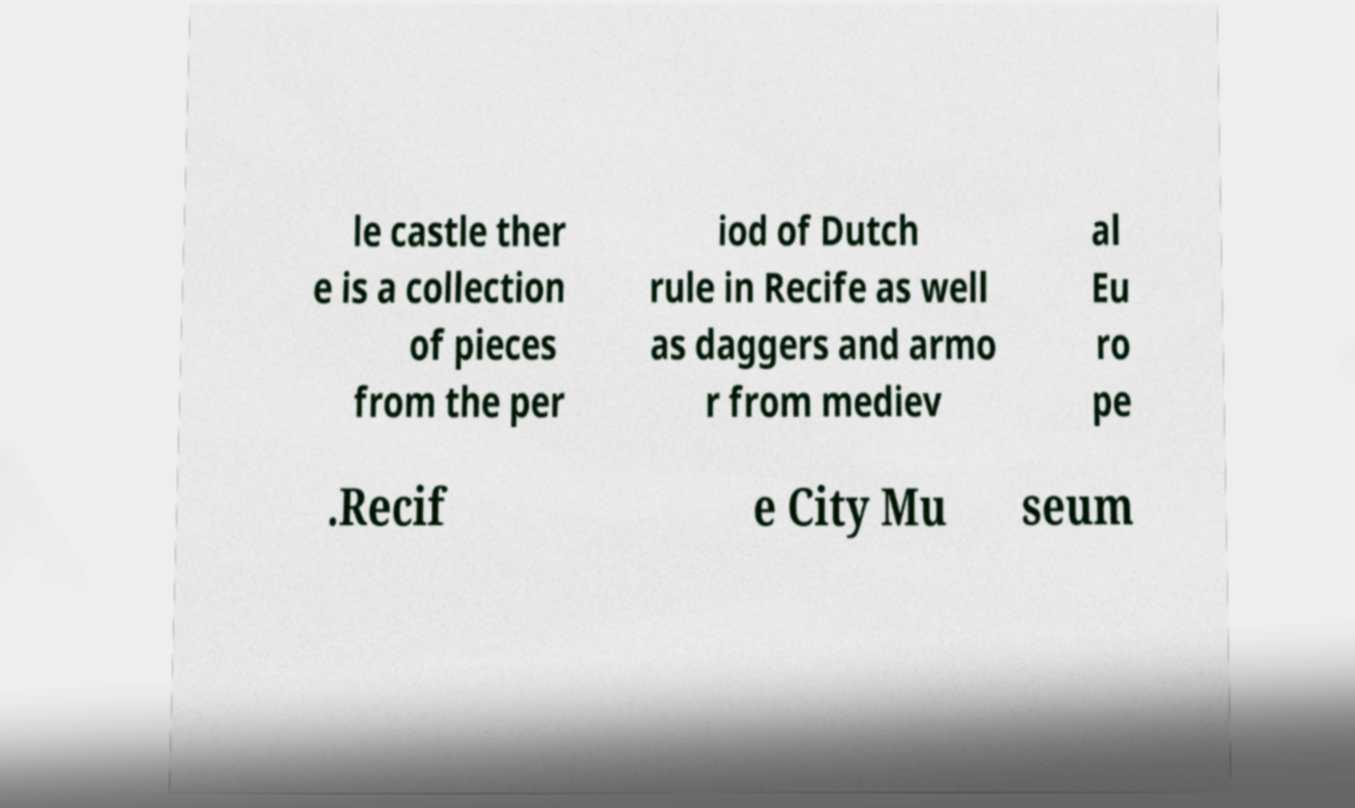Please read and relay the text visible in this image. What does it say? le castle ther e is a collection of pieces from the per iod of Dutch rule in Recife as well as daggers and armo r from mediev al Eu ro pe .Recif e City Mu seum 